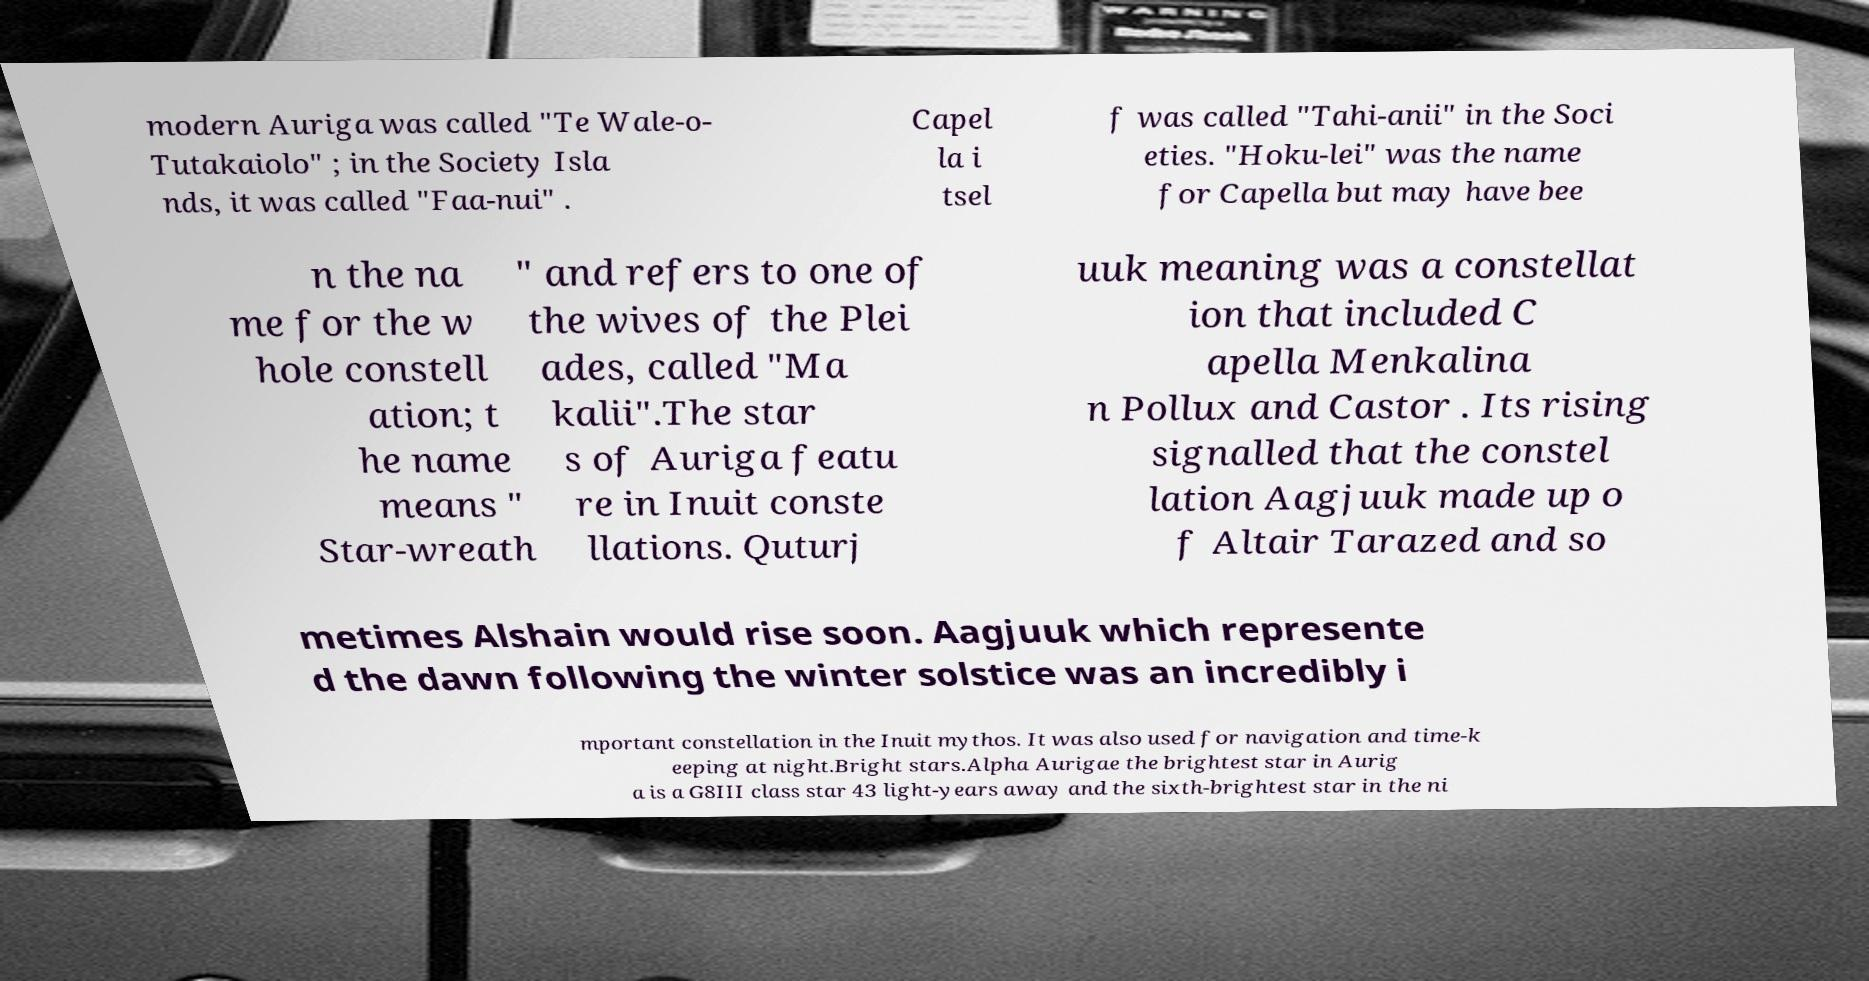I need the written content from this picture converted into text. Can you do that? modern Auriga was called "Te Wale-o- Tutakaiolo" ; in the Society Isla nds, it was called "Faa-nui" . Capel la i tsel f was called "Tahi-anii" in the Soci eties. "Hoku-lei" was the name for Capella but may have bee n the na me for the w hole constell ation; t he name means " Star-wreath " and refers to one of the wives of the Plei ades, called "Ma kalii".The star s of Auriga featu re in Inuit conste llations. Quturj uuk meaning was a constellat ion that included C apella Menkalina n Pollux and Castor . Its rising signalled that the constel lation Aagjuuk made up o f Altair Tarazed and so metimes Alshain would rise soon. Aagjuuk which represente d the dawn following the winter solstice was an incredibly i mportant constellation in the Inuit mythos. It was also used for navigation and time-k eeping at night.Bright stars.Alpha Aurigae the brightest star in Aurig a is a G8III class star 43 light-years away and the sixth-brightest star in the ni 